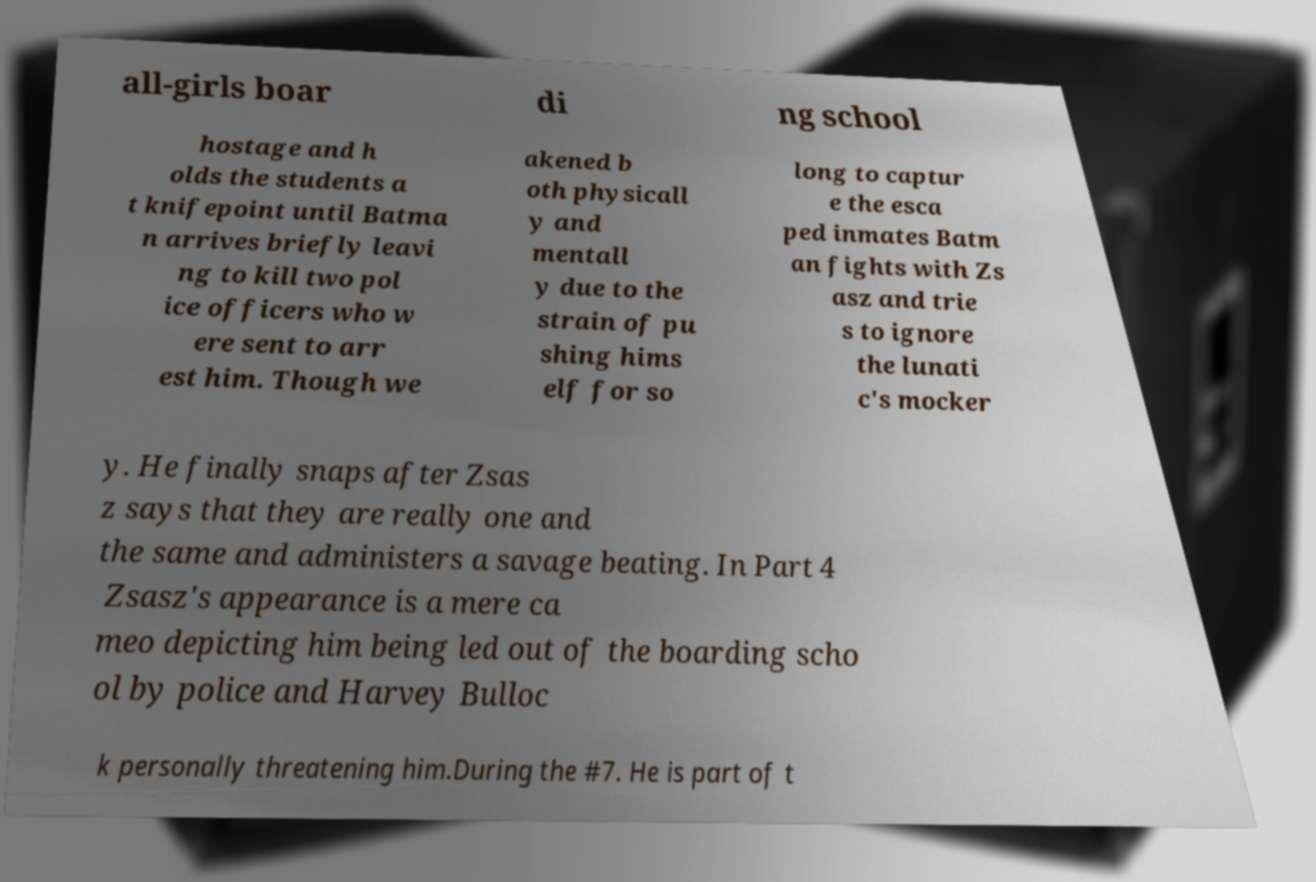Please identify and transcribe the text found in this image. all-girls boar di ng school hostage and h olds the students a t knifepoint until Batma n arrives briefly leavi ng to kill two pol ice officers who w ere sent to arr est him. Though we akened b oth physicall y and mentall y due to the strain of pu shing hims elf for so long to captur e the esca ped inmates Batm an fights with Zs asz and trie s to ignore the lunati c's mocker y. He finally snaps after Zsas z says that they are really one and the same and administers a savage beating. In Part 4 Zsasz's appearance is a mere ca meo depicting him being led out of the boarding scho ol by police and Harvey Bulloc k personally threatening him.During the #7. He is part of t 